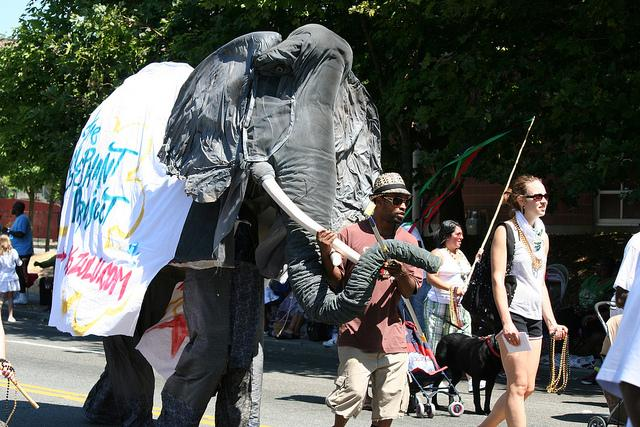What is the ancestral animal of the animal represented here? Please explain your reasoning. woolly mammoth. The animal is a wooly mammoth. 